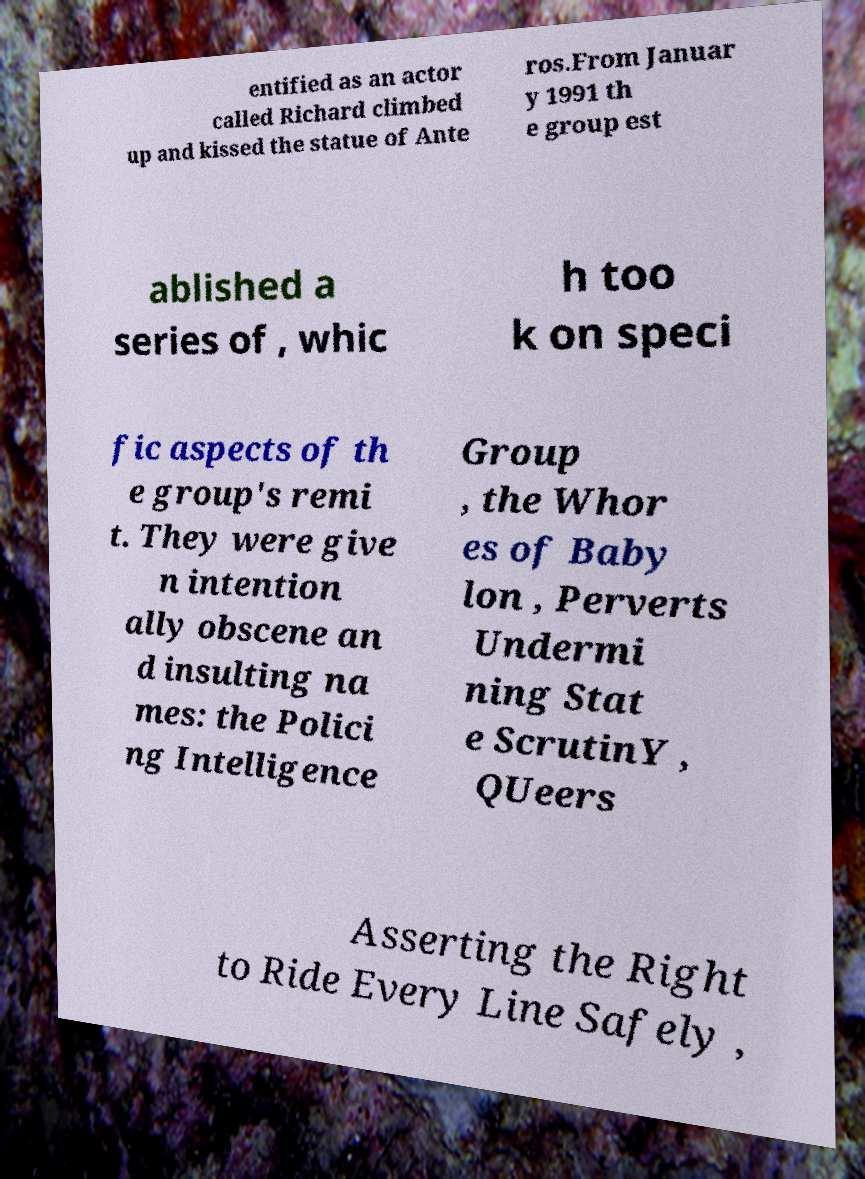Can you accurately transcribe the text from the provided image for me? entified as an actor called Richard climbed up and kissed the statue of Ante ros.From Januar y 1991 th e group est ablished a series of , whic h too k on speci fic aspects of th e group's remi t. They were give n intention ally obscene an d insulting na mes: the Polici ng Intelligence Group , the Whor es of Baby lon , Perverts Undermi ning Stat e ScrutinY , QUeers Asserting the Right to Ride Every Line Safely , 